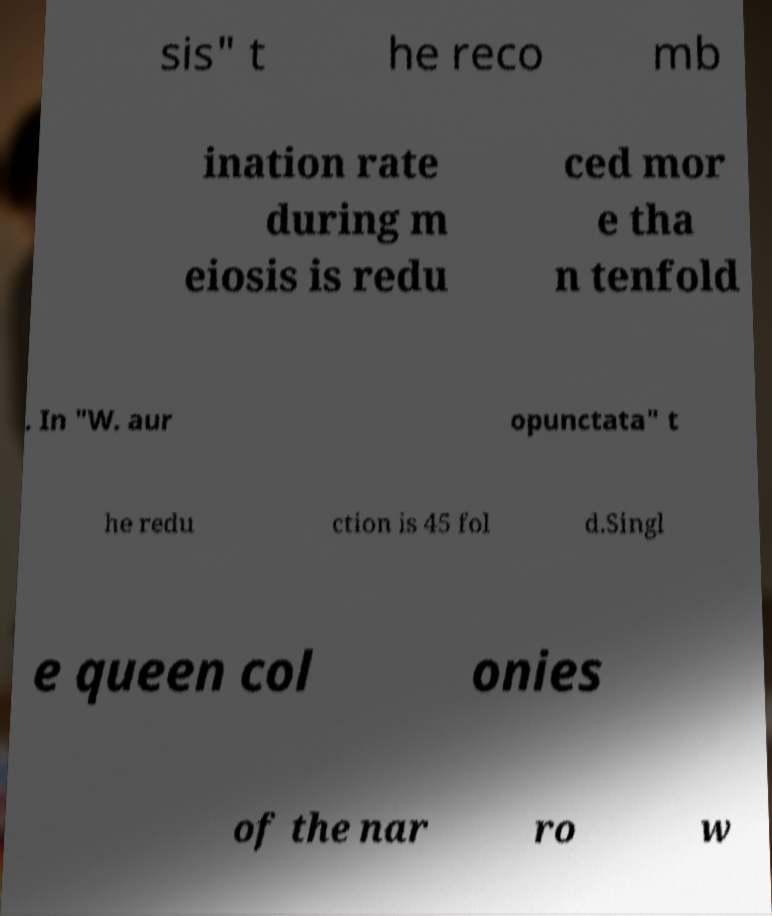What messages or text are displayed in this image? I need them in a readable, typed format. sis" t he reco mb ination rate during m eiosis is redu ced mor e tha n tenfold . In "W. aur opunctata" t he redu ction is 45 fol d.Singl e queen col onies of the nar ro w 